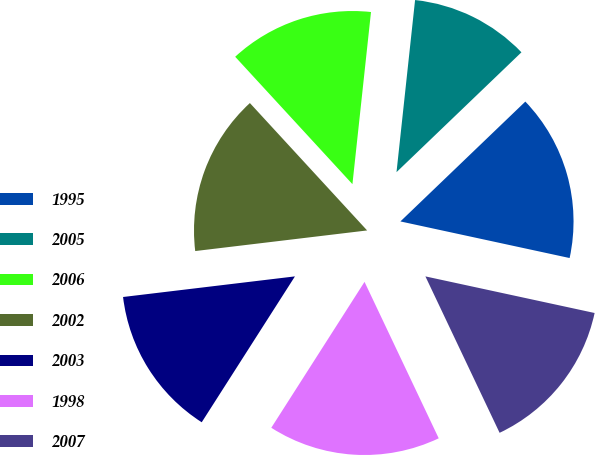Convert chart to OTSL. <chart><loc_0><loc_0><loc_500><loc_500><pie_chart><fcel>1995<fcel>2005<fcel>2006<fcel>2002<fcel>2003<fcel>1998<fcel>2007<nl><fcel>15.56%<fcel>11.12%<fcel>13.55%<fcel>15.06%<fcel>14.05%<fcel>16.1%<fcel>14.56%<nl></chart> 